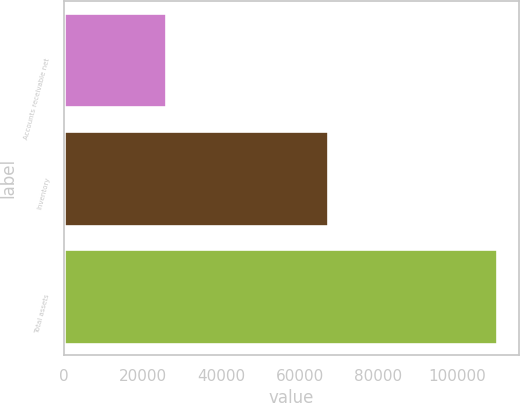<chart> <loc_0><loc_0><loc_500><loc_500><bar_chart><fcel>Accounts receivable net<fcel>Inventory<fcel>Total assets<nl><fcel>26115<fcel>67309<fcel>110301<nl></chart> 